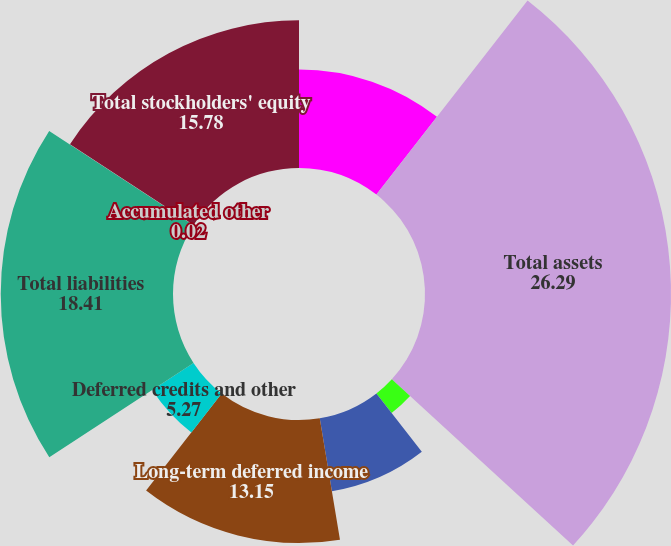Convert chart. <chart><loc_0><loc_0><loc_500><loc_500><pie_chart><fcel>Investments and long-term<fcel>Total assets<fcel>Payroll and benefits payable<fcel>Defined benefit postretirement<fcel>Long-term deferred income<fcel>Deferred credits and other<fcel>Total liabilities<fcel>Accumulated other<fcel>Total stockholders' equity<nl><fcel>10.53%<fcel>26.29%<fcel>2.65%<fcel>7.9%<fcel>13.15%<fcel>5.27%<fcel>18.41%<fcel>0.02%<fcel>15.78%<nl></chart> 